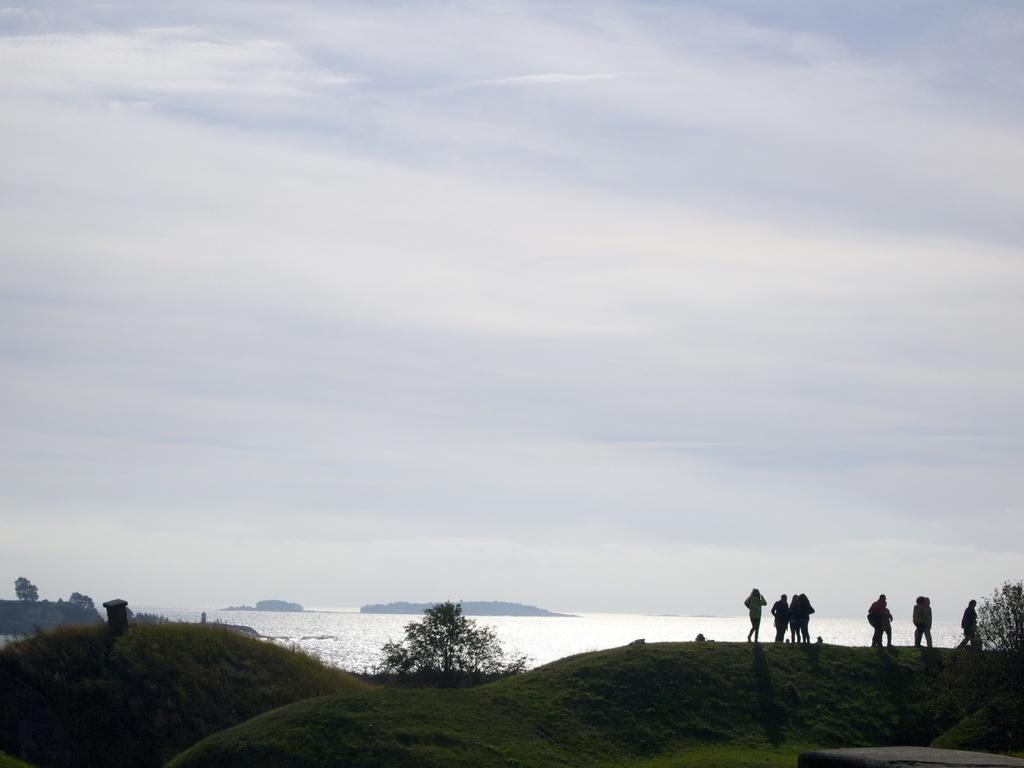What type of vegetation can be seen in the image? There is grass and trees visible in the image. What natural element is present in the image? There is water visible in the image. Are there any people in the image? Yes, there are people standing in the image. How would you describe the sky in the background of the image? The sky is cloudy in the background of the image. What type of judge can be seen in the image? There is no judge present in the image. What substance is being used by the hen in the image? There is no hen present in the image. 